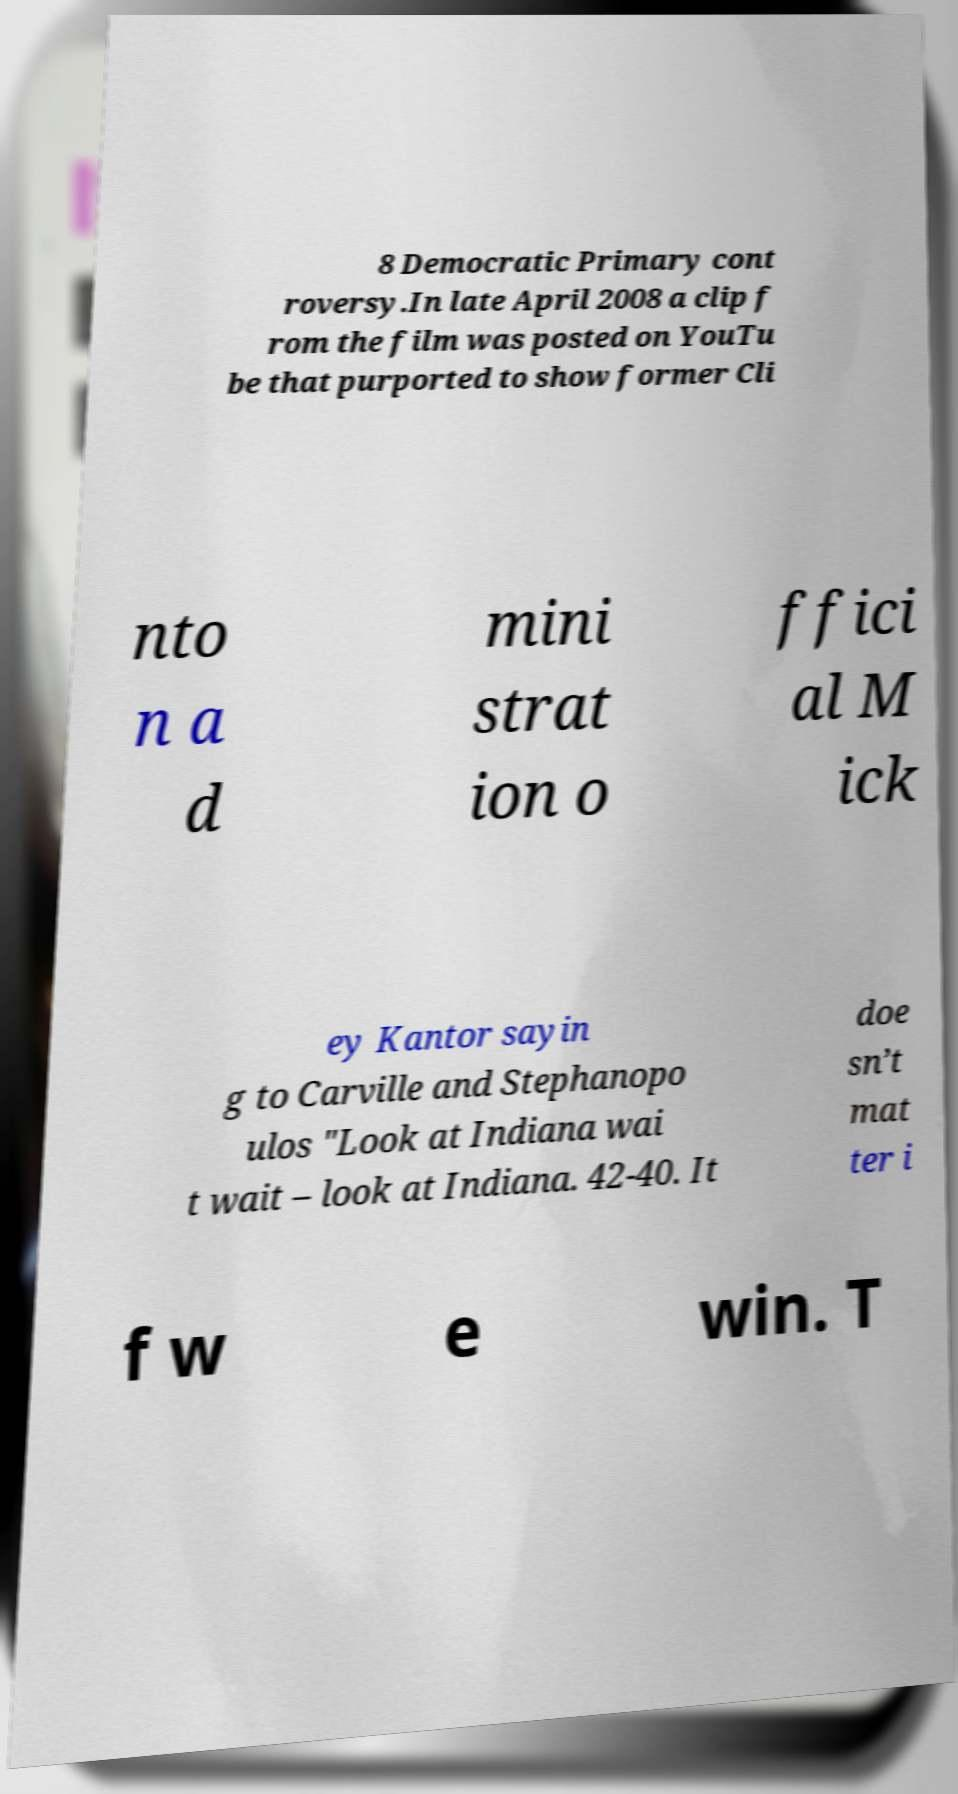Can you read and provide the text displayed in the image?This photo seems to have some interesting text. Can you extract and type it out for me? 8 Democratic Primary cont roversy.In late April 2008 a clip f rom the film was posted on YouTu be that purported to show former Cli nto n a d mini strat ion o ffici al M ick ey Kantor sayin g to Carville and Stephanopo ulos "Look at Indiana wai t wait – look at Indiana. 42-40. It doe sn’t mat ter i f w e win. T 